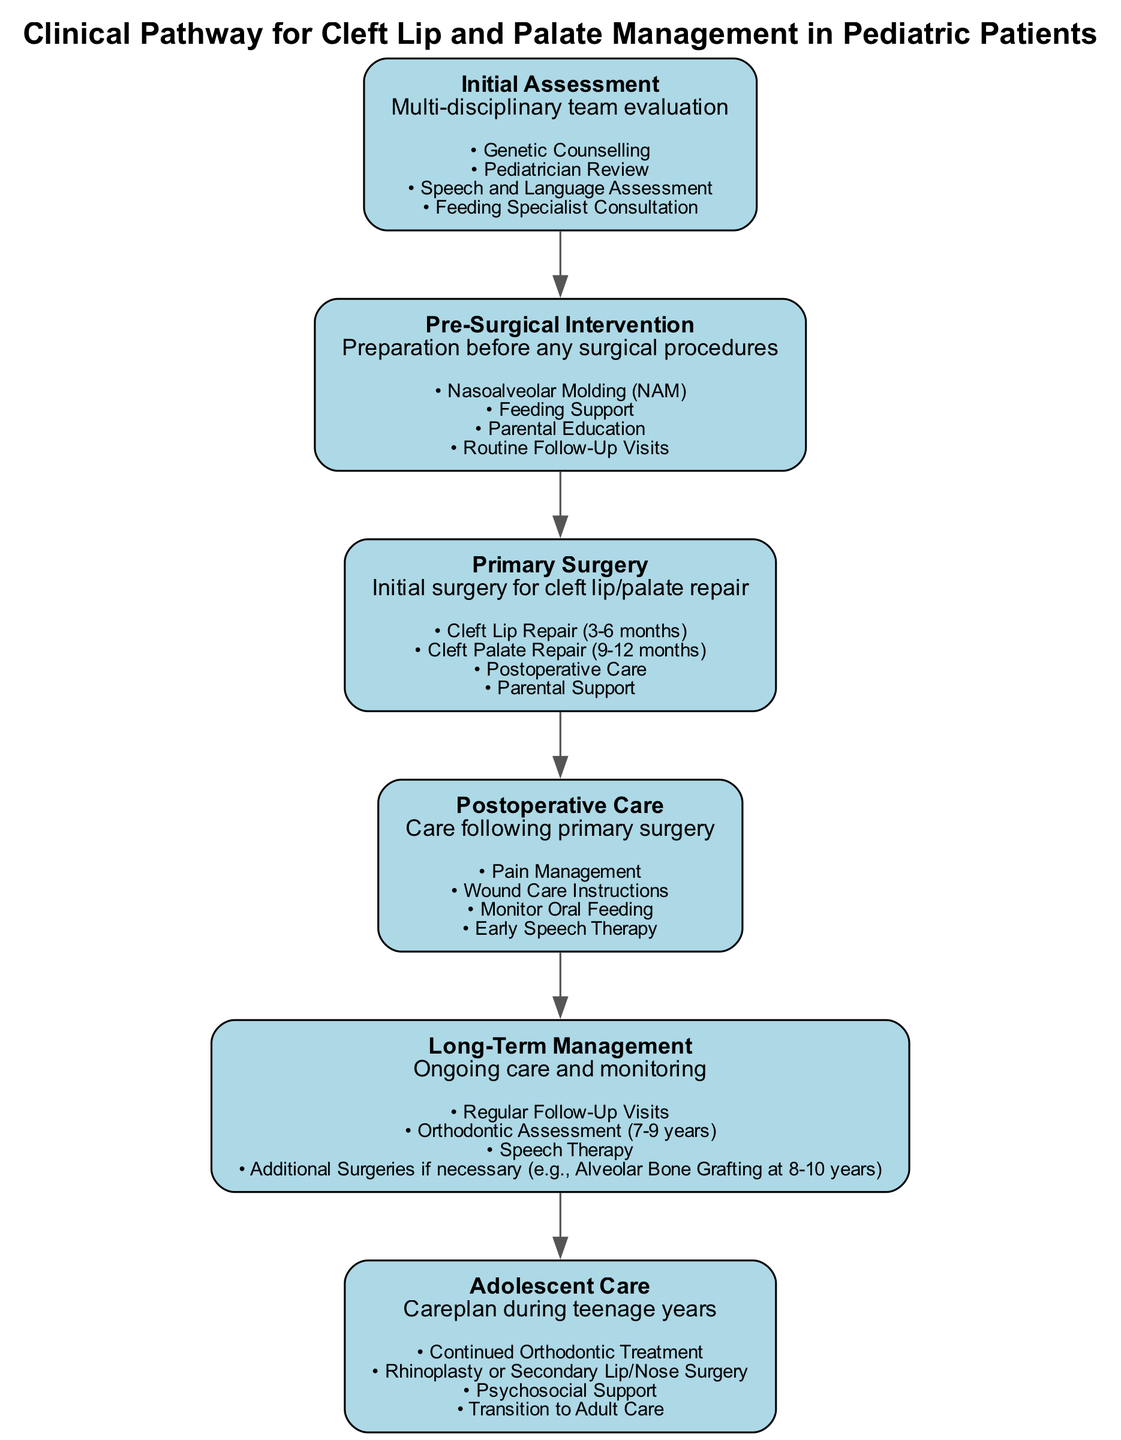What is the first step in the clinical pathway? The diagram identifies the first step as "Initial Assessment". It is labeled at the top of the flowchart, making it easy to identify.
Answer: Initial Assessment How many key activities are involved in the "Postoperative Care"? By examining the section for "Postoperative Care", we can see that there are four key activities listed. Counting them gives a total of four activities.
Answer: 4 What is the description of the "Primary Surgery" step? Looking at the "Primary Surgery" section in the diagram, it states the description as "Initial surgery for cleft lip/palate repair", which is clearly mentioned below the step title.
Answer: Initial surgery for cleft lip/palate repair What follows "Pre-Surgical Intervention" in the pathway? The flow of the diagram shows that the next step after "Pre-Surgical Intervention" is "Primary Surgery", with a directed edge connecting the two steps.
Answer: Primary Surgery Which key activities are included in "Long-Term Management"? In the "Long-Term Management" section, the diagram lists four activities including "Regular Follow-Up Visits" and "Orthodontic Assessment (7-9 years)", among others.
Answer: Regular Follow-Up Visits, Orthodontic Assessment (7-9 years), Speech Therapy, Additional Surgeries if necessary What age is suggested for "Cleft Lip Repair"? The "Primary Surgery" section indicates that "Cleft Lip Repair" is typically performed at 3-6 months of age, which is a specific detail provided in the key activities.
Answer: 3-6 months Is there a step for adolescent care? The diagram includes a distinct step labeled "Adolescent Care", which supports the concern for ongoing management as patients age.
Answer: Yes How many total steps are displayed in the clinical pathway? By counting all the labeled steps in the diagram, there are six distinct steps outlined in the clinical pathway.
Answer: 6 